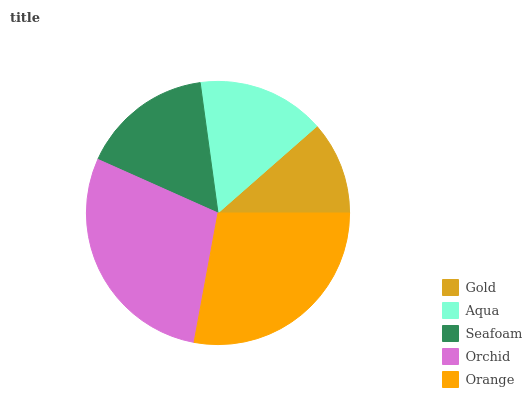Is Gold the minimum?
Answer yes or no. Yes. Is Orchid the maximum?
Answer yes or no. Yes. Is Aqua the minimum?
Answer yes or no. No. Is Aqua the maximum?
Answer yes or no. No. Is Aqua greater than Gold?
Answer yes or no. Yes. Is Gold less than Aqua?
Answer yes or no. Yes. Is Gold greater than Aqua?
Answer yes or no. No. Is Aqua less than Gold?
Answer yes or no. No. Is Seafoam the high median?
Answer yes or no. Yes. Is Seafoam the low median?
Answer yes or no. Yes. Is Aqua the high median?
Answer yes or no. No. Is Orchid the low median?
Answer yes or no. No. 